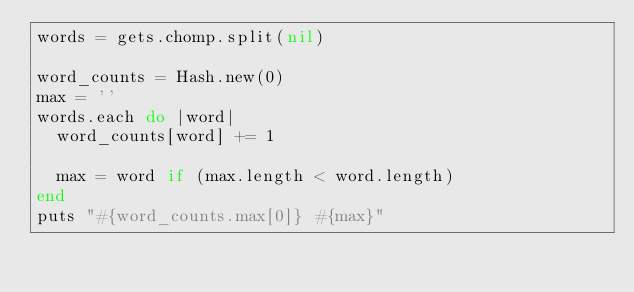Convert code to text. <code><loc_0><loc_0><loc_500><loc_500><_Ruby_>words = gets.chomp.split(nil)

word_counts = Hash.new(0)
max = ''
words.each do |word|
  word_counts[word] += 1

  max = word if (max.length < word.length)
end
puts "#{word_counts.max[0]} #{max}"</code> 